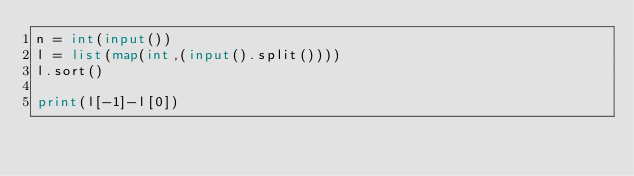Convert code to text. <code><loc_0><loc_0><loc_500><loc_500><_Python_>n = int(input())
l = list(map(int,(input().split()))) 
l.sort()

print(l[-1]-l[0])
</code> 